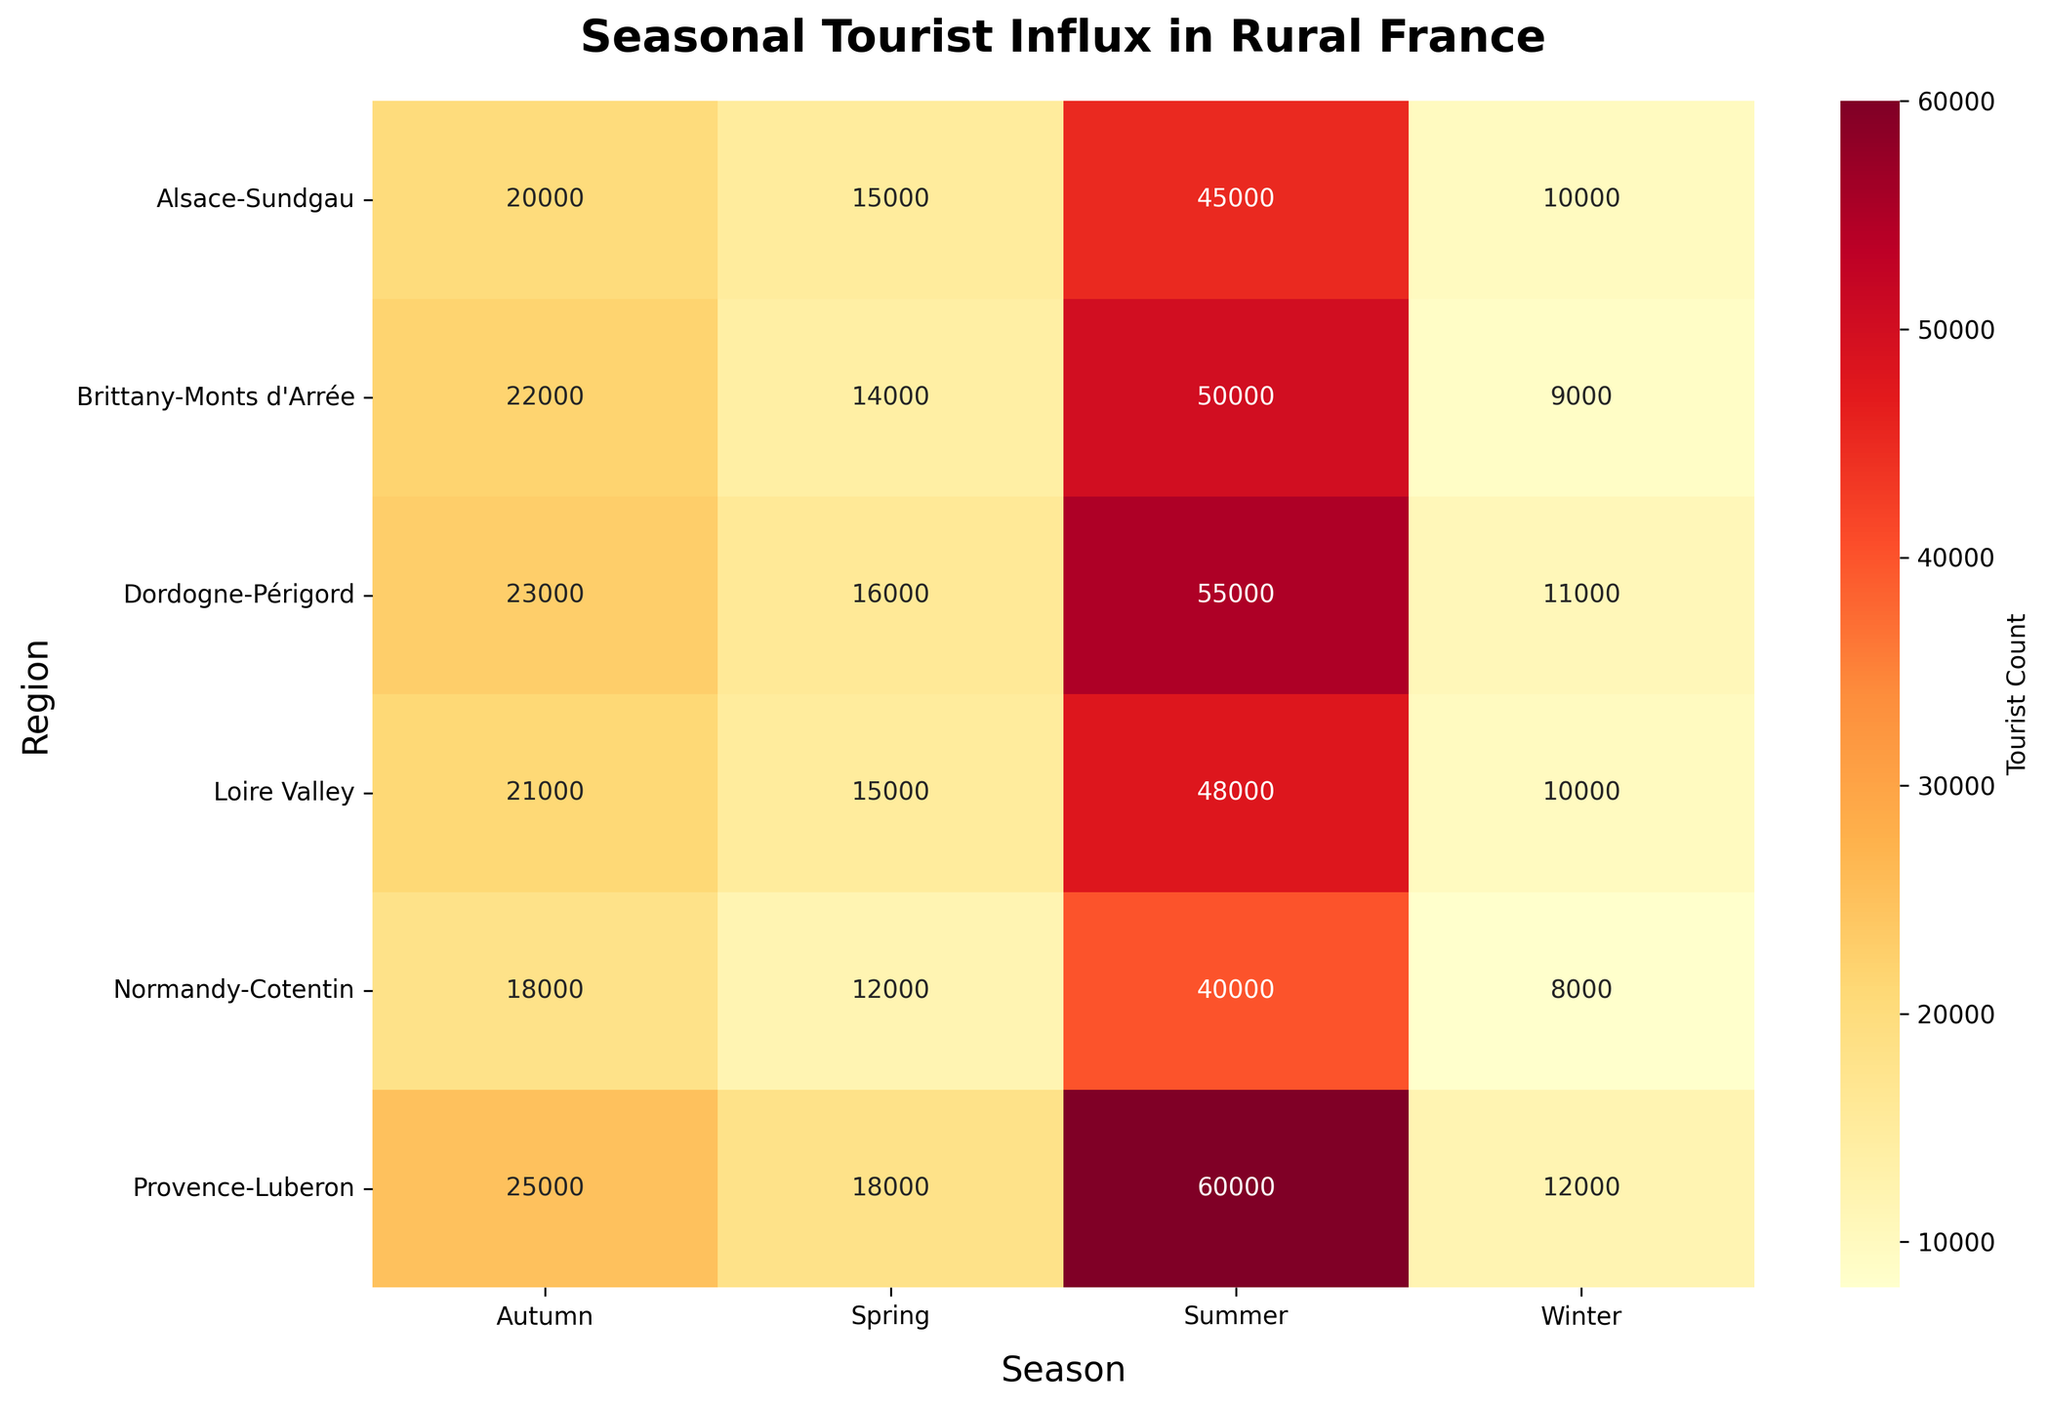Which region has the highest tourist count in the summer? By checking the heatmap, look for the region with the darkest color in the summer column, which corresponds to the highest tourist count. Provence-Luberon has the darkest color.
Answer: Provence-Luberon During which season does Normandy-Cotentin have the lowest tourist influx? To find the lowest influx, look for the lightest color shade in the Normandy-Cotentin row. This is seen under Winter.
Answer: Winter What's the total tourist count for Alsace-Sundgau across all seasons? Add the numbers from all four seasons for Alsace-Sundgau: 15,000 (Spring) + 45,000 (Summer) + 20,000 (Autumn) + 10,000 (Winter) = 90,000.
Answer: 90,000 Which region sees a higher tourist count in Autumn, Brittany-Monts d'Arrée or Dordogne-Périgord? Compare the figures for Autumn in both regions from the heatmap. Brittany-Monts d'Arrée has 22,000 and Dordogne-Périgord has 23,000. Dordogne-Périgord is higher.
Answer: Dordogne-Périgord Which season generally has the highest tourist influx across all regions? Assess the overall color intensity in each season column. Summer has the darkest shades, indicating it's generally the highest across regions.
Answer: Summer How many regions have a tourist count of over 10,000 in Winter? Check each region under Winter and count those with numbers greater than 10,000. Alsace-Sundgau, Provence-Luberon, Dordogne-Périgord, and Loire Valley meet the criteria.
Answer: 4 What is the difference in tourist count between Spring and Autumn for the Loire Valley? Subtract the number in Autumn from the number in Spring for Loire Valley: 15,000 (Spring) and 21,000 (Autumn), so 21,000 - 15,000 = 6,000.
Answer: 6,000 Which regions have a tourist count of exactly 50,000 in any season? Identify the regions with a tourist count of 50,000 in any season by checking the map and find that Brittany-Monts d'Arrée is the only one in Summer.
Answer: Brittany-Monts d'Arrée Does Dordogne-Périgord or Alsace-Sundgau have a higher tourist count in Winter? Look at the numbers for Winter in both regions. Dordogne-Périgord has 11,000 and Alsace-Sundgau has 10,000, so Dordogne-Périgord is higher.
Answer: Dordogne-Périgord 